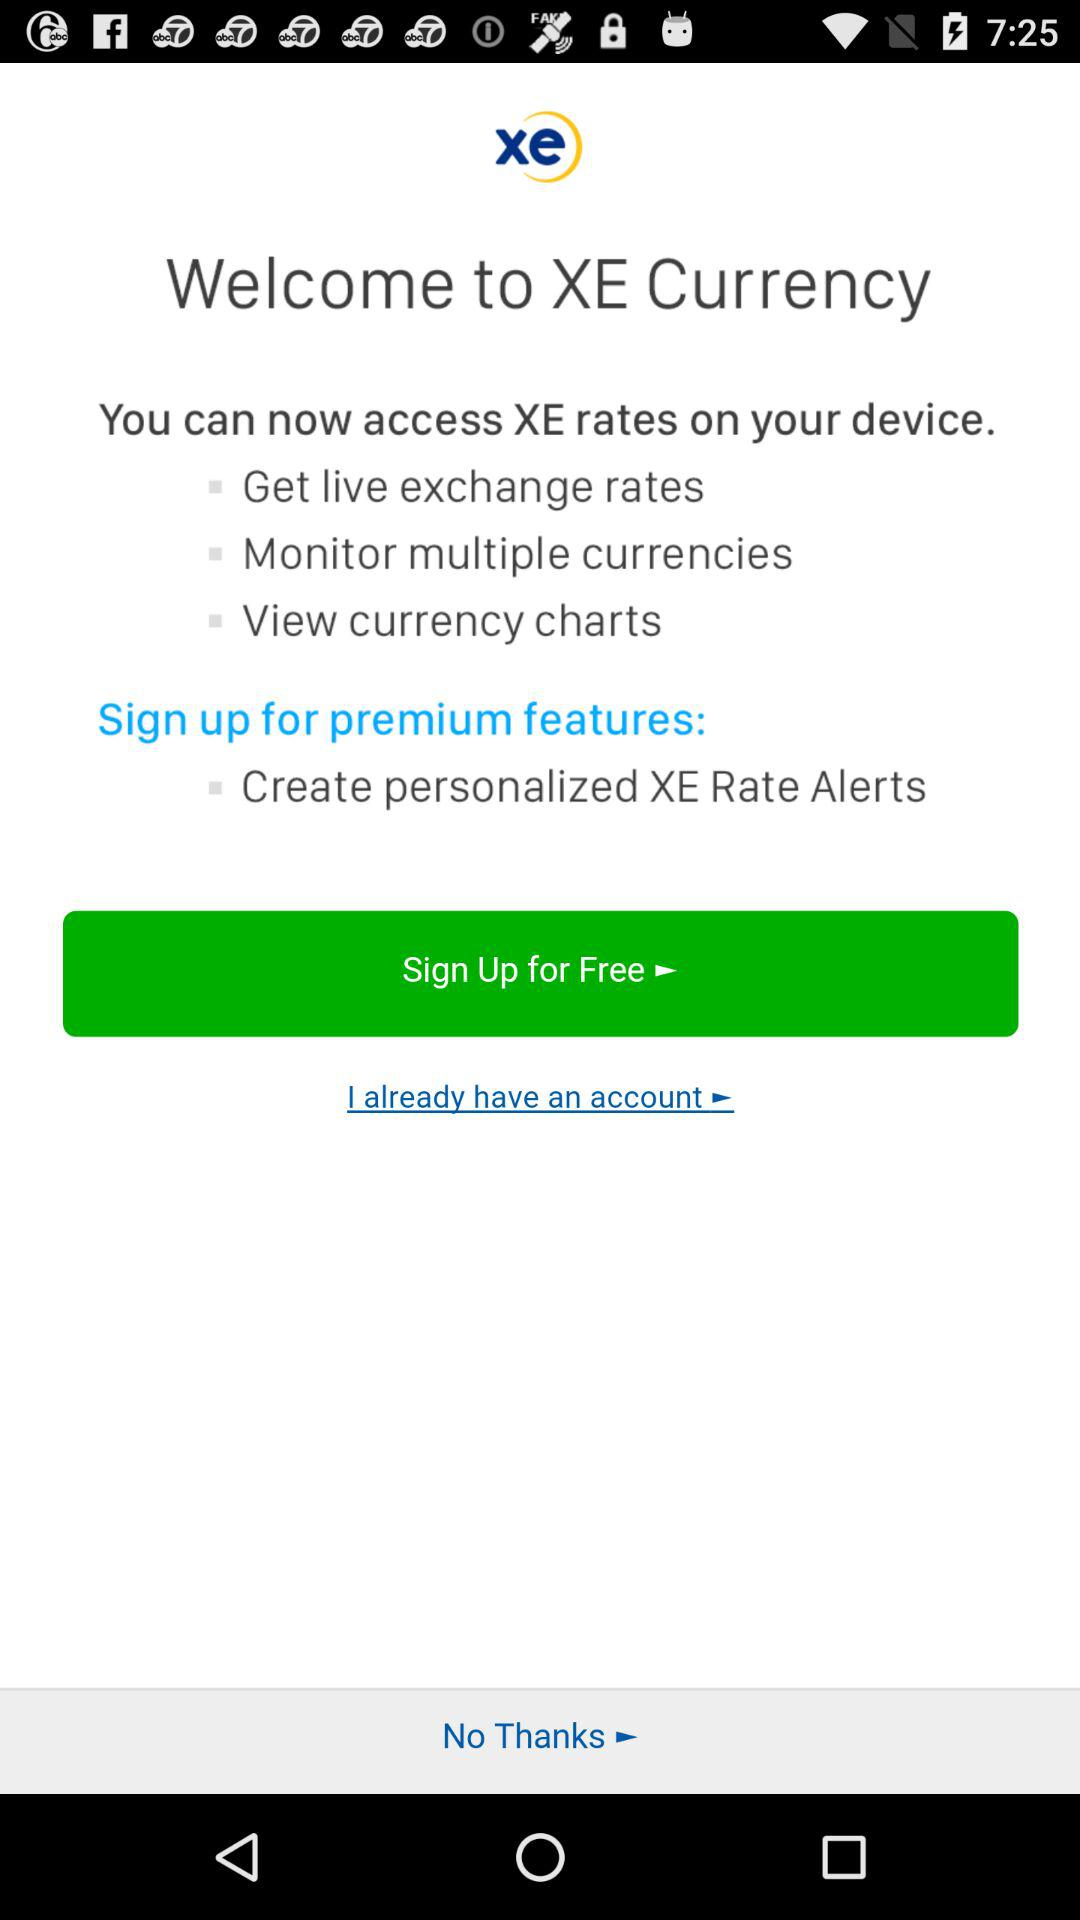What's the sign up cost?
Answer the question using a single word or phrase. It is free. 